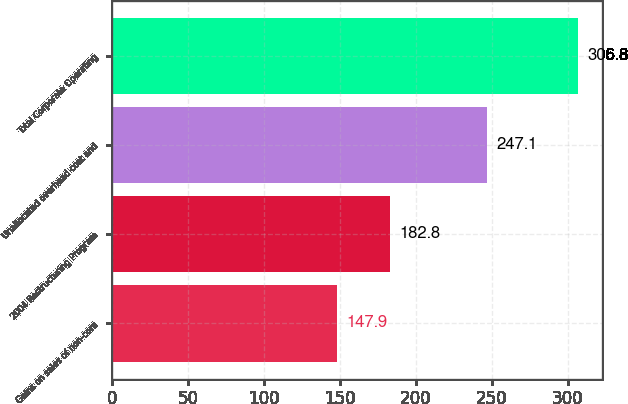<chart> <loc_0><loc_0><loc_500><loc_500><bar_chart><fcel>Gains on sales of non-core<fcel>2004 Restructuring Program<fcel>Unallocated overhead cost and<fcel>Total Corporate Operating<nl><fcel>147.9<fcel>182.8<fcel>247.1<fcel>306.8<nl></chart> 